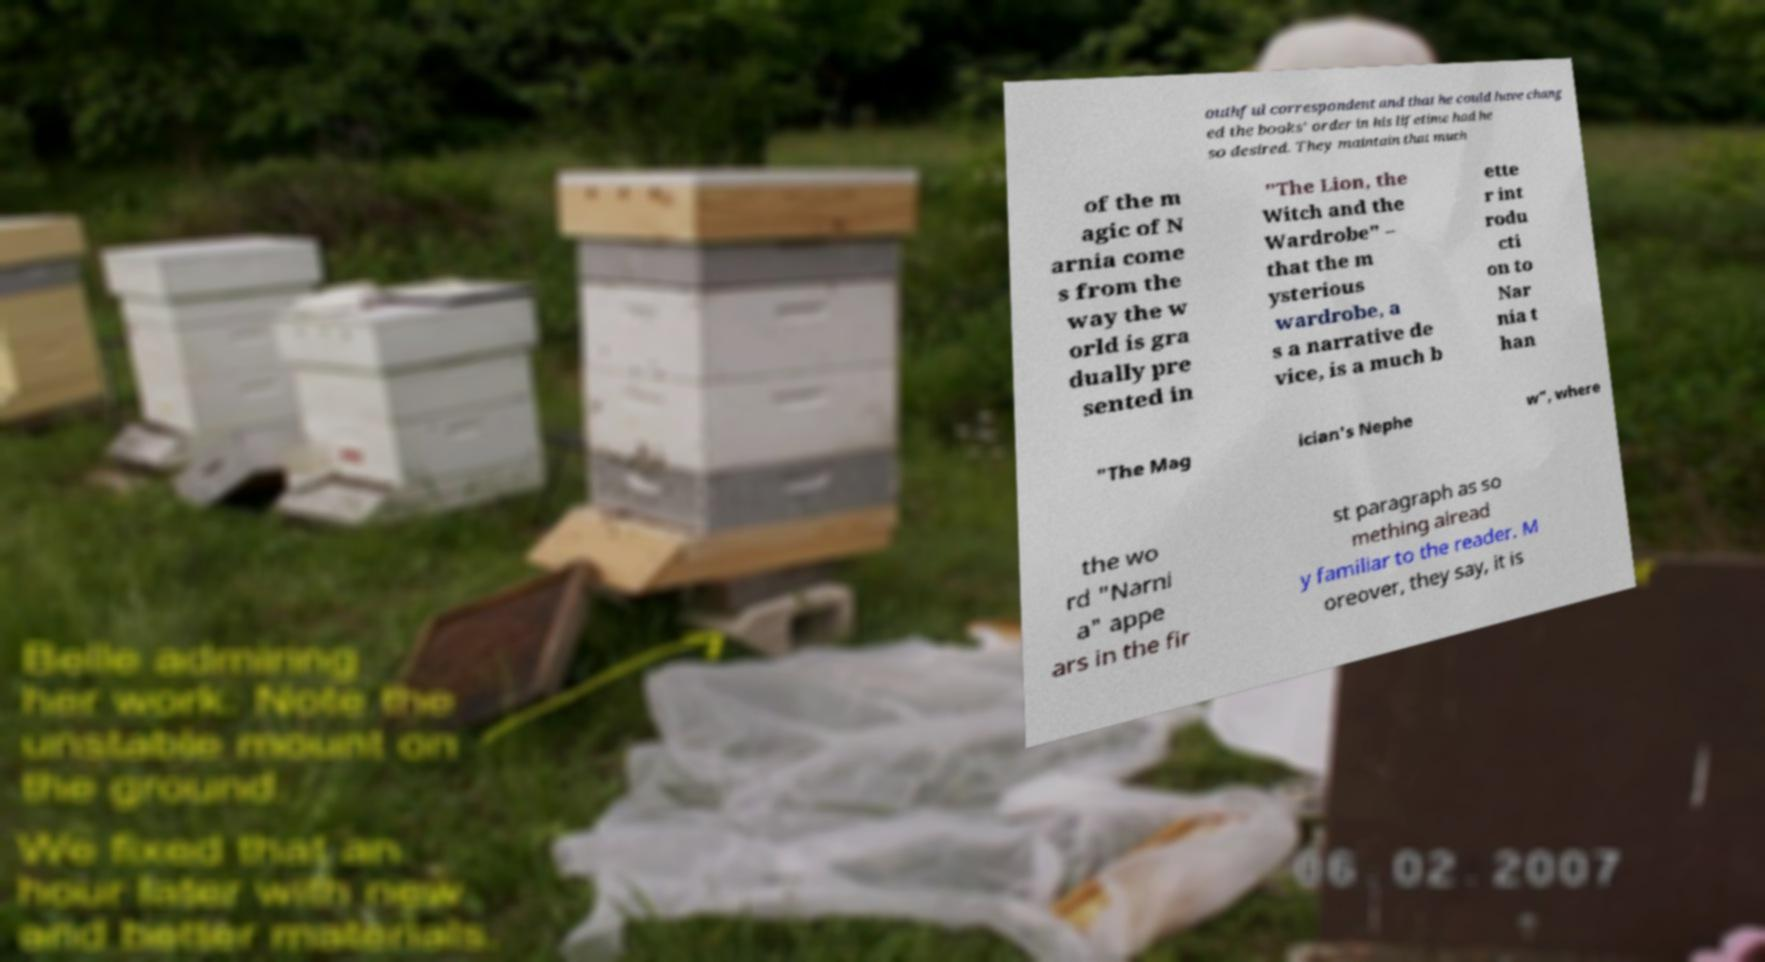Please identify and transcribe the text found in this image. outhful correspondent and that he could have chang ed the books' order in his lifetime had he so desired. They maintain that much of the m agic of N arnia come s from the way the w orld is gra dually pre sented in "The Lion, the Witch and the Wardrobe" – that the m ysterious wardrobe, a s a narrative de vice, is a much b ette r int rodu cti on to Nar nia t han "The Mag ician's Nephe w", where the wo rd "Narni a" appe ars in the fir st paragraph as so mething alread y familiar to the reader. M oreover, they say, it is 